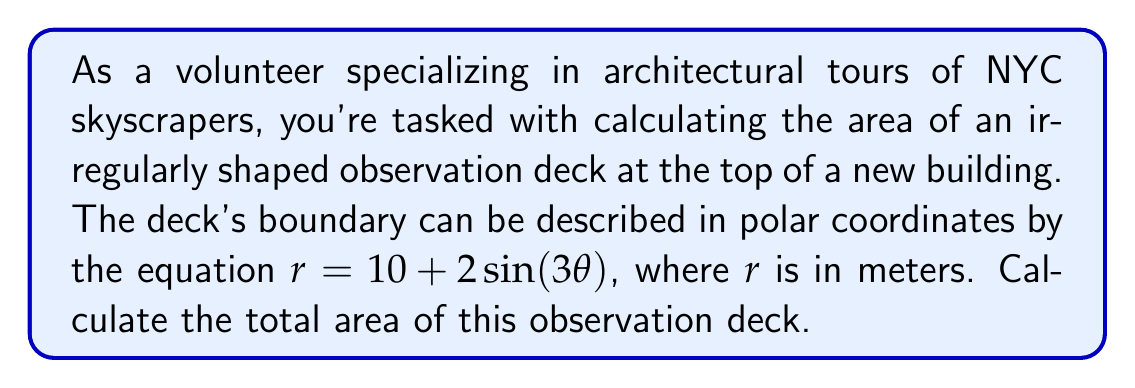Solve this math problem. To calculate the area of this irregularly shaped observation deck, we'll use polar integration. The steps are as follows:

1) The general formula for area in polar coordinates is:

   $$A = \frac{1}{2} \int_0^{2\pi} r^2 d\theta$$

2) In this case, $r = 10 + 2\sin(3\theta)$. We need to square this:

   $$r^2 = (10 + 2\sin(3\theta))^2 = 100 + 40\sin(3\theta) + 4\sin^2(3\theta)$$

3) Now, let's set up our integral:

   $$A = \frac{1}{2} \int_0^{2\pi} (100 + 40\sin(3\theta) + 4\sin^2(3\theta)) d\theta$$

4) Let's integrate each term separately:

   a) $\int_0^{2\pi} 100 d\theta = 100\theta \big|_0^{2\pi} = 200\pi$

   b) $\int_0^{2\pi} 40\sin(3\theta) d\theta = -\frac{40}{3}\cos(3\theta) \big|_0^{2\pi} = 0$

   c) For $\int_0^{2\pi} 4\sin^2(3\theta) d\theta$, we can use the identity $\sin^2 x = \frac{1-\cos(2x)}{2}$:
      
      $$\int_0^{2\pi} 4\sin^2(3\theta) d\theta = \int_0^{2\pi} 2(1-\cos(6\theta)) d\theta = 2\theta - \frac{1}{3}\sin(6\theta) \big|_0^{2\pi} = 4\pi$$

5) Adding these results and multiplying by $\frac{1}{2}$:

   $$A = \frac{1}{2}(200\pi + 0 + 4\pi) = 102\pi$$

Therefore, the area of the observation deck is $102\pi$ square meters.
Answer: $102\pi$ square meters 